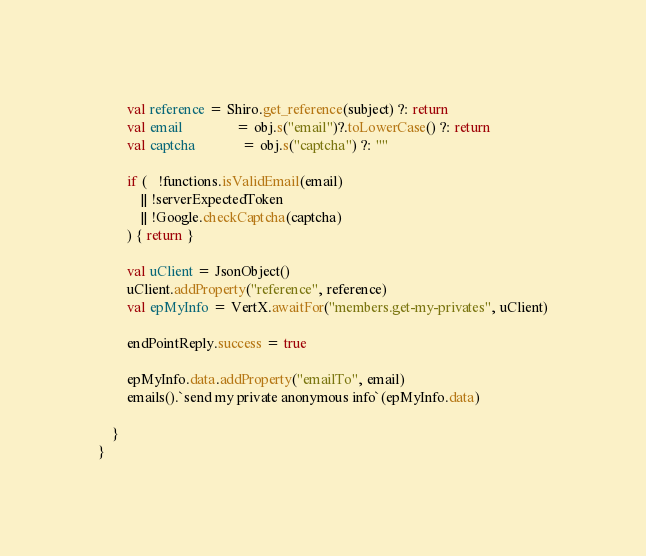<code> <loc_0><loc_0><loc_500><loc_500><_Kotlin_>        val reference = Shiro.get_reference(subject) ?: return
        val email               = obj.s("email")?.toLowerCase() ?: return
        val captcha             = obj.s("captcha") ?: ""

        if (   !functions.isValidEmail(email)
            || !serverExpectedToken
            || !Google.checkCaptcha(captcha)
        ) { return }

        val uClient = JsonObject()
        uClient.addProperty("reference", reference)
        val epMyInfo = VertX.awaitFor("members.get-my-privates", uClient)

        endPointReply.success = true

        epMyInfo.data.addProperty("emailTo", email)
        emails().`send my private anonymous info`(epMyInfo.data)

    }
}</code> 